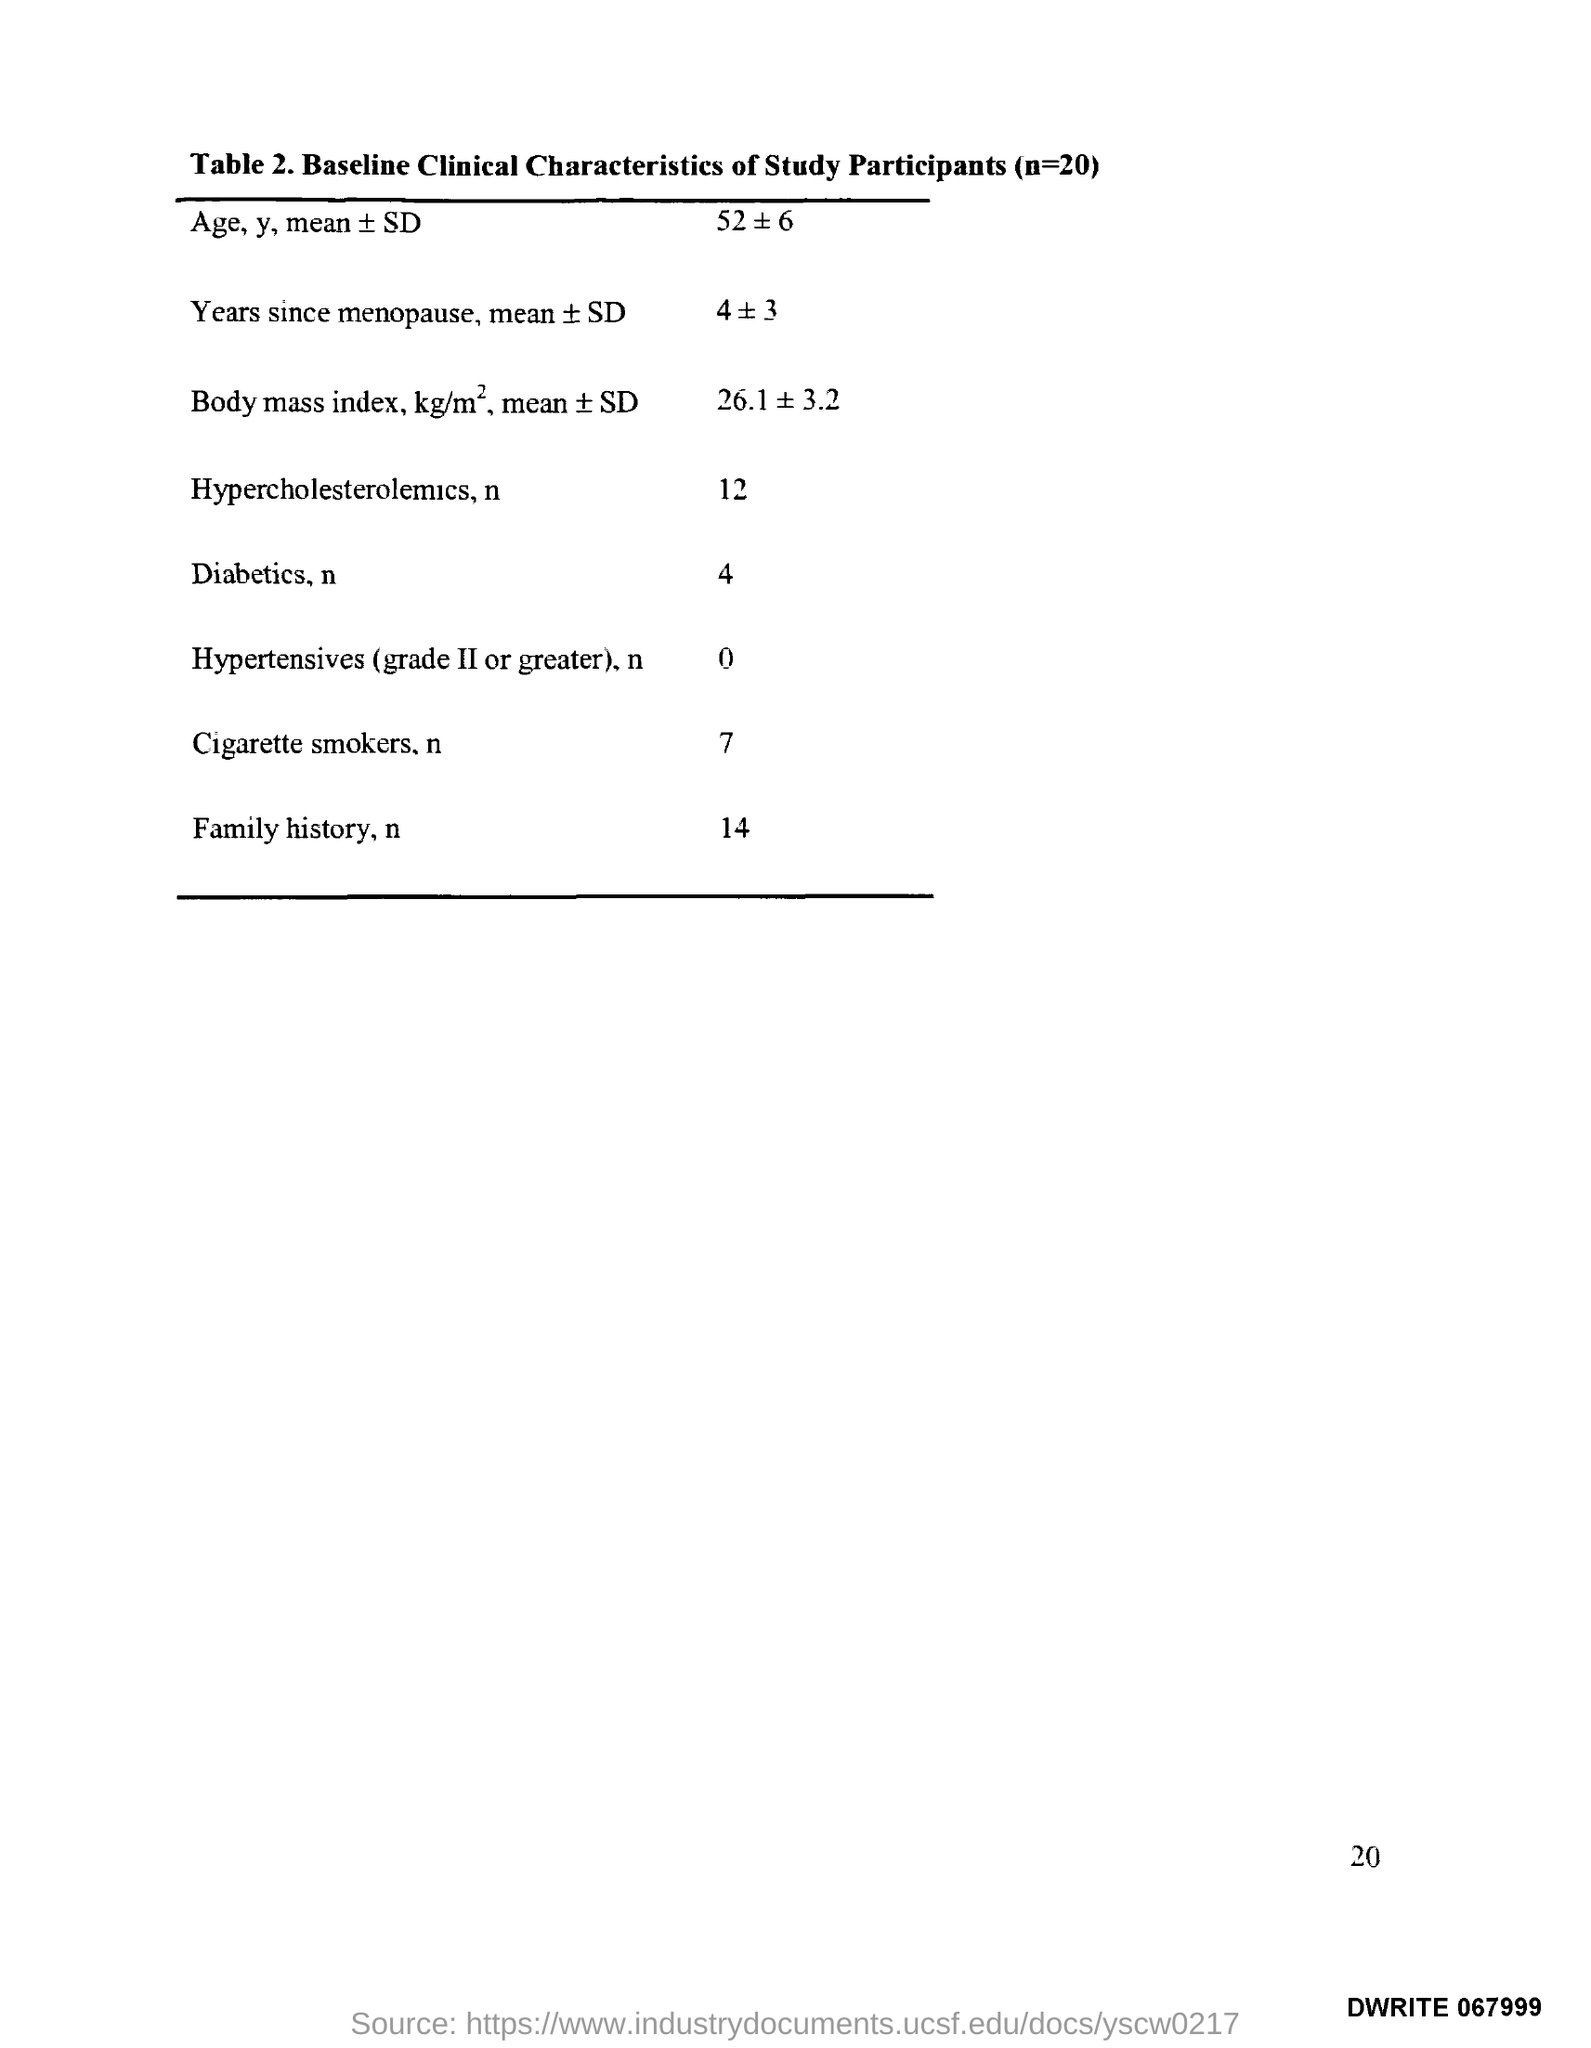Identify some key points in this picture. Table 2 in this document provides a description of the baseline clinical characteristics of all study participants, numbering 20. 